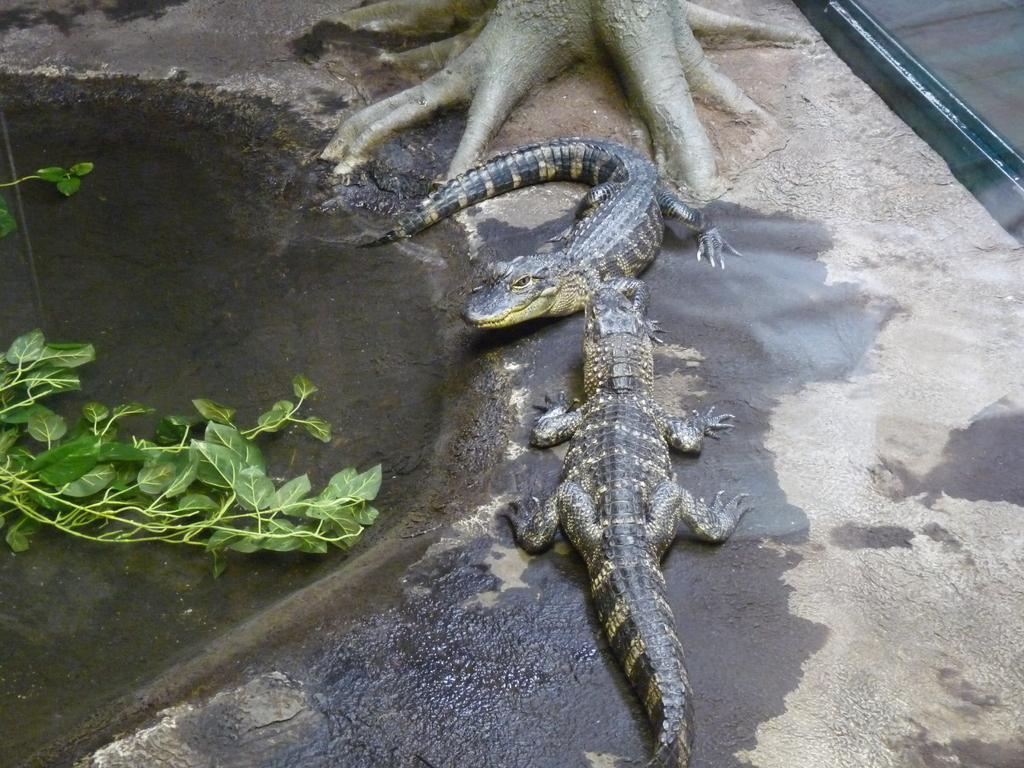What type of animals can be seen in the image? There are crocodiles in the image. What part of a tree can be seen in the image? There are roots of a tree in the image. What is floating on the water on the left side of the image? There are leaves in the water on the left side of the image. What type of insurance policy is being discussed by the crocodiles in the image? There is no indication in the image that the crocodiles are discussing any insurance policies. 